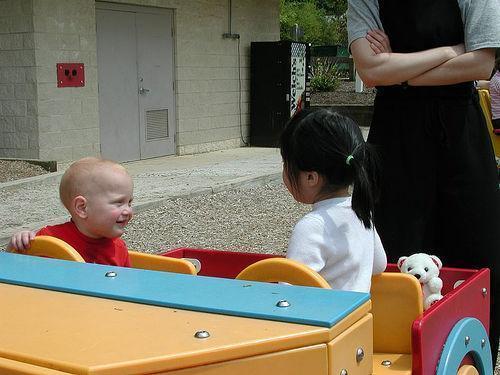How many adults are in the picture?
Give a very brief answer. 1. How many people are in the photo?
Give a very brief answer. 3. 